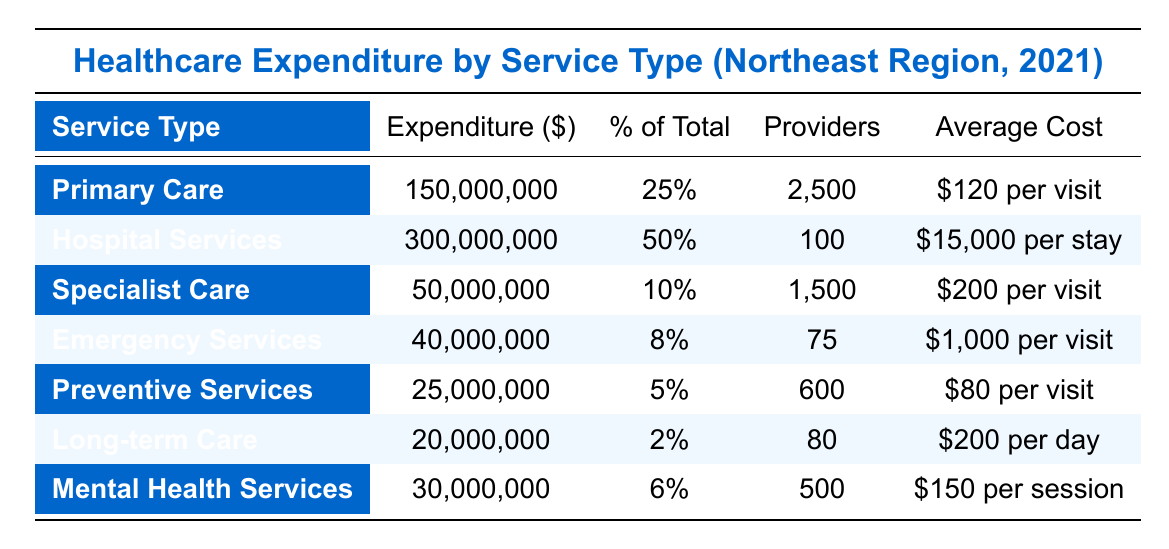What is the total healthcare expenditure in the Northeast for 2021? By adding all the expenditures from each service type: 150,000,000 + 300,000,000 + 50,000,000 + 40,000,000 + 25,000,000 + 20,000,000 + 30,000,000 = 615,000,000.
Answer: 615,000,000 Which service type has the highest expenditure? The highest expenditure is noted in the Hospital Services row, which has an expenditure of 300,000,000.
Answer: Hospital Services What percentage of total expenditure is allocated to Primary Care? The table states that Primary Care has an expenditure of 150,000,000 which is 25% of the total expenditure.
Answer: 25% How many providers offer Emergency Services? The table shows that Emergency Services are provided by 75 providers.
Answer: 75 Is the expenditure on Mental Health Services greater than or equal to that on Long-term Care? The table lists Mental Health Services expenditure at 30,000,000 and Long-term Care at 20,000,000. Since 30,000,000 is greater than 20,000,000, the statement is true.
Answer: Yes What is the average cost per visit for Specialist Care? The table indicates that the average cost per visit for Specialist Care is 200.
Answer: 200 What is the combined expenditure for Preventive Services and Long-term Care? By adding the expenditures for Preventive Services (25,000,000) and Long-term Care (20,000,000): 25,000,000 + 20,000,000 = 45,000,000.
Answer: 45,000,000 What percentage of the total healthcare expenditure does Emergency Services represent? The table shows that Emergency Services have an expenditure of 40,000,000, which is 8% of the total. This can be confirmed by the column labeled % of Total.
Answer: 8% If there are 1,500 providers for Specialist Care, what is the average cost per session? The average cost per session for Specialist Care is given in the table as 200. This is directly stated, so there is no need for calculations here.
Answer: 200 